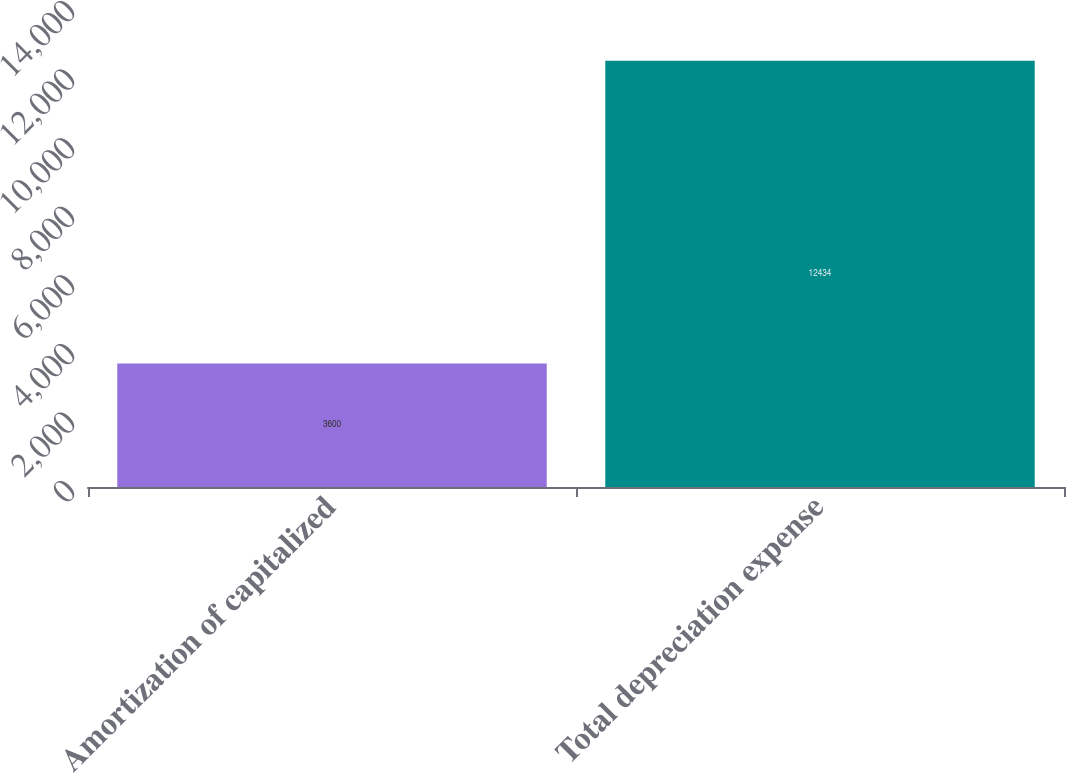<chart> <loc_0><loc_0><loc_500><loc_500><bar_chart><fcel>Amortization of capitalized<fcel>Total depreciation expense<nl><fcel>3600<fcel>12434<nl></chart> 